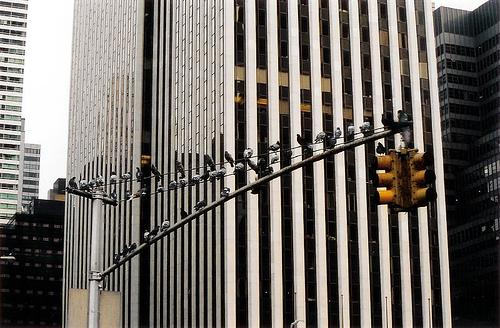What are the birds perched on? Please explain your reasoning. traffic light. The birds are on top of lights. 